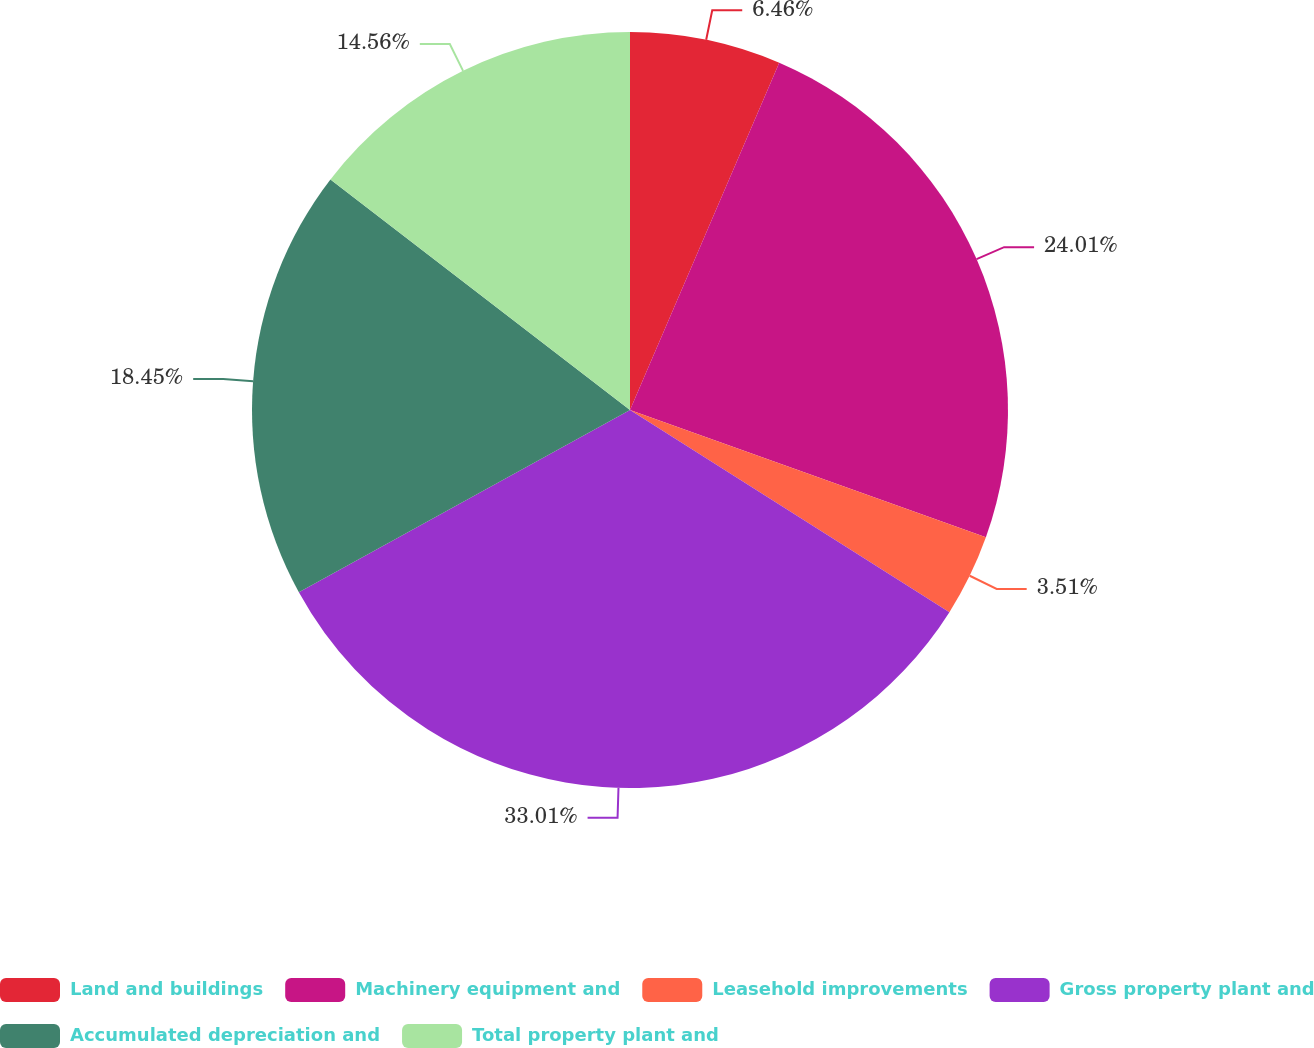Convert chart to OTSL. <chart><loc_0><loc_0><loc_500><loc_500><pie_chart><fcel>Land and buildings<fcel>Machinery equipment and<fcel>Leasehold improvements<fcel>Gross property plant and<fcel>Accumulated depreciation and<fcel>Total property plant and<nl><fcel>6.46%<fcel>24.01%<fcel>3.51%<fcel>33.01%<fcel>18.45%<fcel>14.56%<nl></chart> 